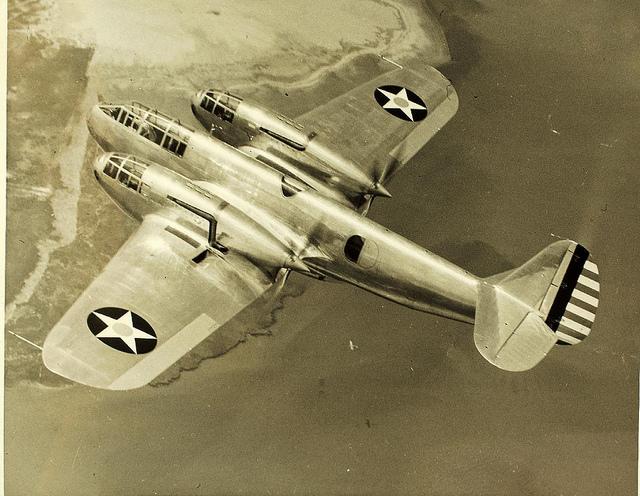What country is this plane from?
Give a very brief answer. Usa. What is on the plane's wings?
Write a very short answer. Stars. What war had these types of planes?
Answer briefly. Wwii. 